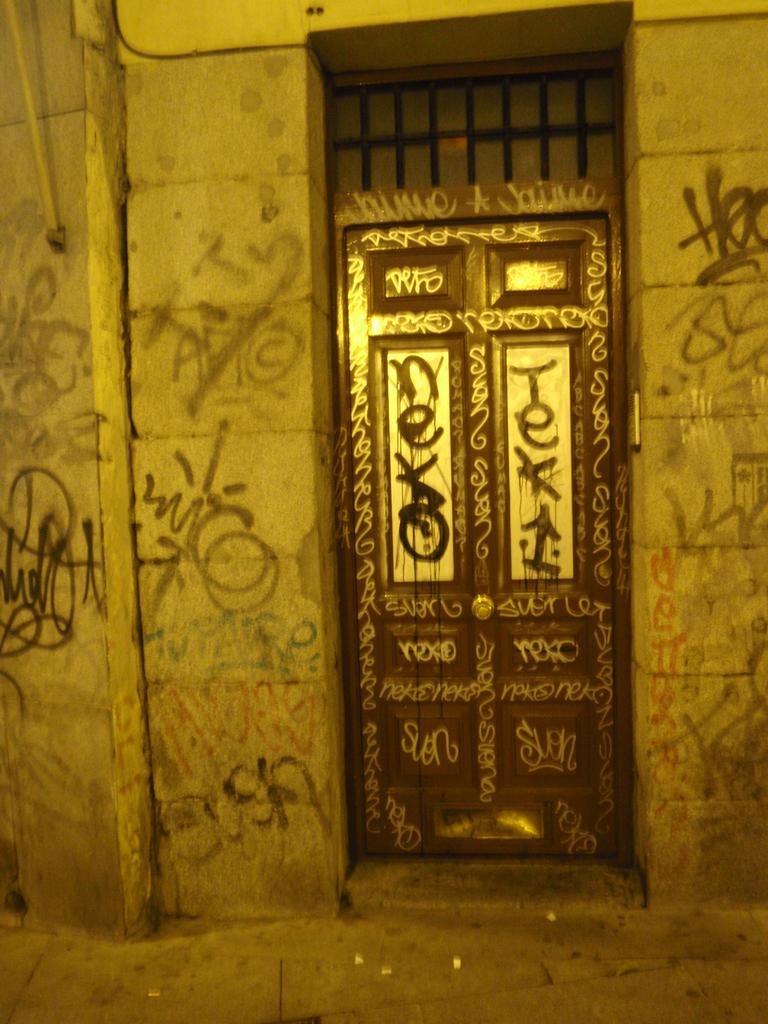Describe this image in one or two sentences. In this image there is a closed wooden door. On top of the door there is a window with grill rods. Beside the door on the wall there is some text written. 